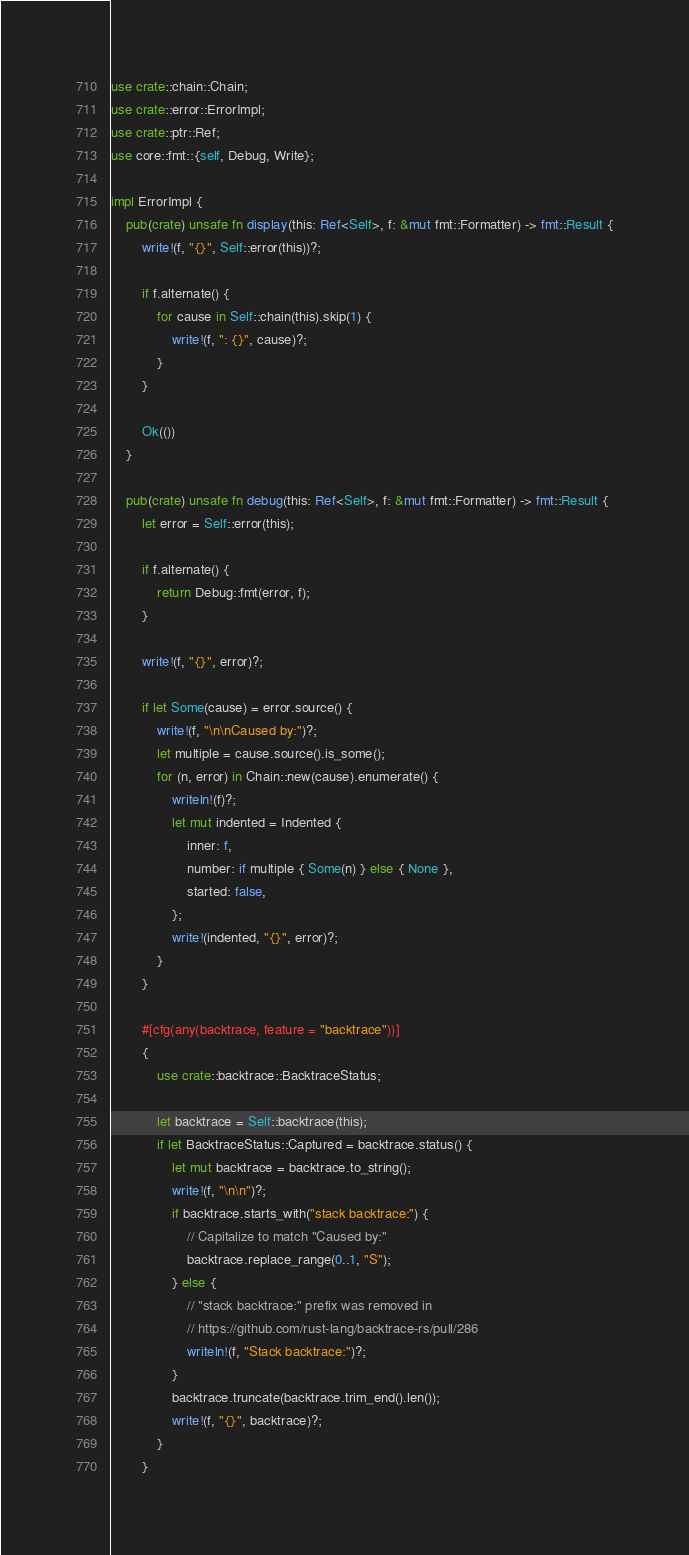Convert code to text. <code><loc_0><loc_0><loc_500><loc_500><_Rust_>use crate::chain::Chain;
use crate::error::ErrorImpl;
use crate::ptr::Ref;
use core::fmt::{self, Debug, Write};

impl ErrorImpl {
    pub(crate) unsafe fn display(this: Ref<Self>, f: &mut fmt::Formatter) -> fmt::Result {
        write!(f, "{}", Self::error(this))?;

        if f.alternate() {
            for cause in Self::chain(this).skip(1) {
                write!(f, ": {}", cause)?;
            }
        }

        Ok(())
    }

    pub(crate) unsafe fn debug(this: Ref<Self>, f: &mut fmt::Formatter) -> fmt::Result {
        let error = Self::error(this);

        if f.alternate() {
            return Debug::fmt(error, f);
        }

        write!(f, "{}", error)?;

        if let Some(cause) = error.source() {
            write!(f, "\n\nCaused by:")?;
            let multiple = cause.source().is_some();
            for (n, error) in Chain::new(cause).enumerate() {
                writeln!(f)?;
                let mut indented = Indented {
                    inner: f,
                    number: if multiple { Some(n) } else { None },
                    started: false,
                };
                write!(indented, "{}", error)?;
            }
        }

        #[cfg(any(backtrace, feature = "backtrace"))]
        {
            use crate::backtrace::BacktraceStatus;

            let backtrace = Self::backtrace(this);
            if let BacktraceStatus::Captured = backtrace.status() {
                let mut backtrace = backtrace.to_string();
                write!(f, "\n\n")?;
                if backtrace.starts_with("stack backtrace:") {
                    // Capitalize to match "Caused by:"
                    backtrace.replace_range(0..1, "S");
                } else {
                    // "stack backtrace:" prefix was removed in
                    // https://github.com/rust-lang/backtrace-rs/pull/286
                    writeln!(f, "Stack backtrace:")?;
                }
                backtrace.truncate(backtrace.trim_end().len());
                write!(f, "{}", backtrace)?;
            }
        }
</code> 